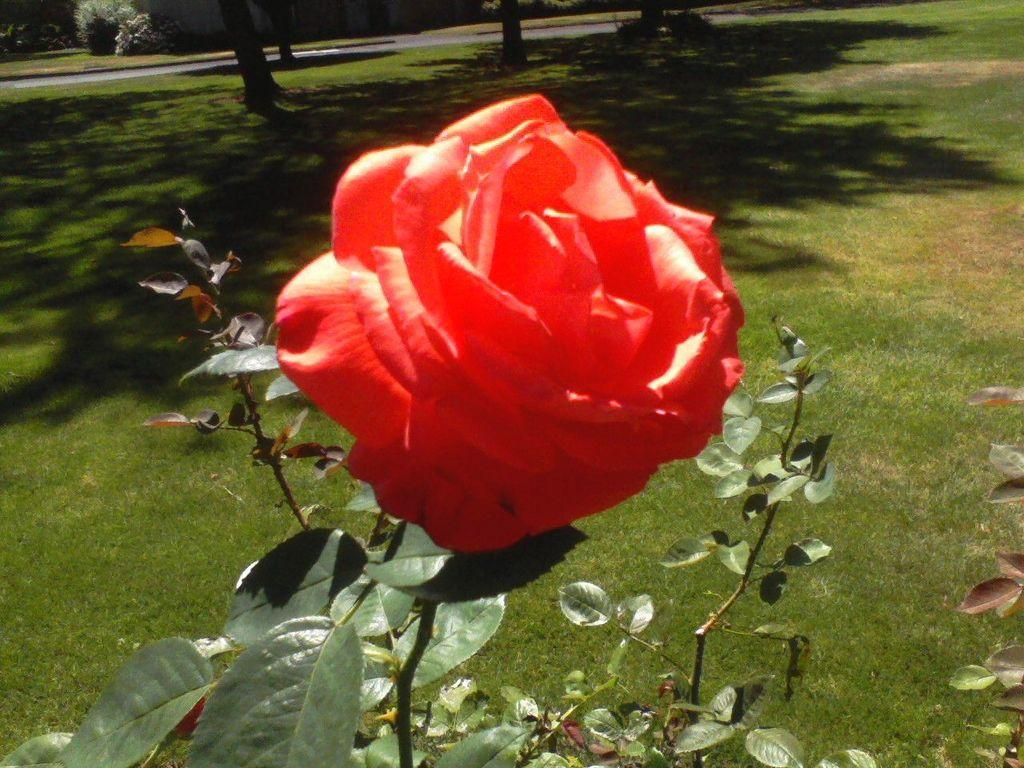What can be seen in the foreground of the picture? In the foreground of the picture, there are leaves, stems, a rose flower, and grass. Can you describe the main subject in the foreground? The main subject in the foreground is a rose flower. What is visible in the background of the picture? In the background of the picture, there are trees, plants, grass, and other objects. How many types of vegetation can be seen in the picture? There are at least four types of vegetation visible: leaves, stems, grass, and trees. What note is the family playing on the piano in the background of the image? There is no piano or family present in the image; it features various types of vegetation in the foreground and background. How does the digestion process of the plants in the image work? The image does not provide information about the digestion process of the plants; it only shows their physical appearance. 